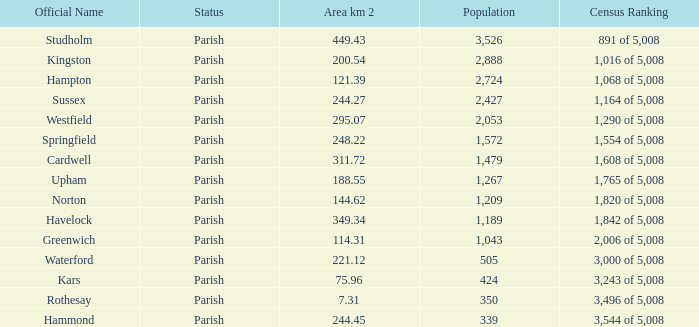What is the area in square kilometers of Studholm? 1.0. 